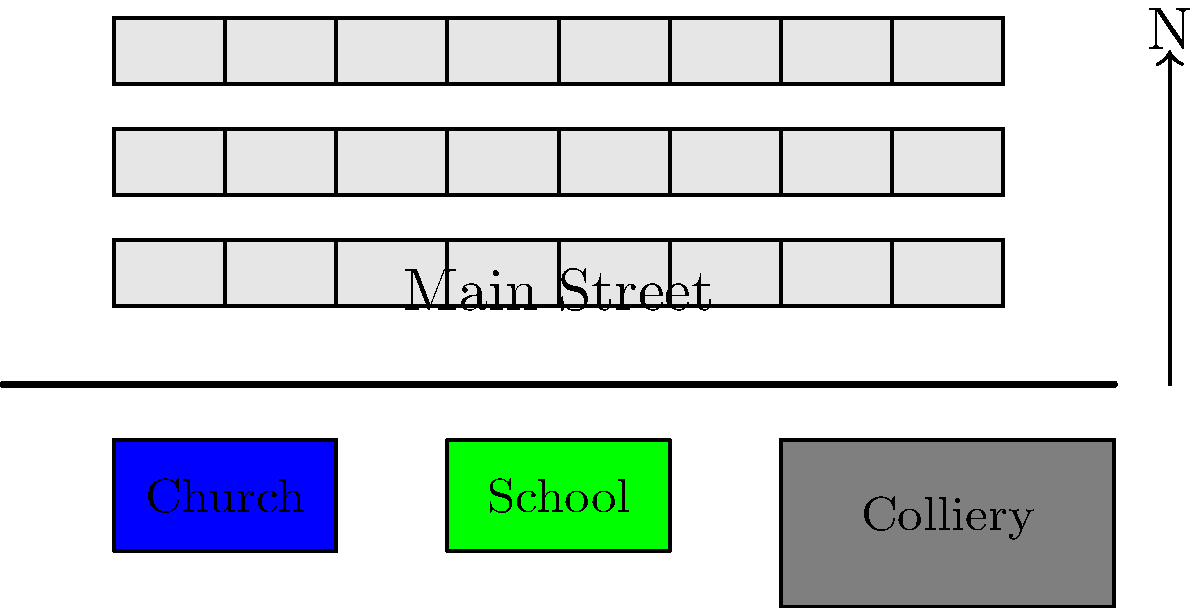In the typical layout of a Northumberland pit village, what is the significance of the positioning of the colliery in relation to the residential area, and how does this arrangement reflect the socio-economic structure of these communities? To understand the significance of the colliery's position in a Northumberland pit village, we need to consider several factors:

1. Proximity: The colliery is typically located at one end of the village, close to the residential area. This proximity allowed miners to easily walk to work, reducing transportation needs.

2. Prevailing winds: The colliery is often positioned downwind from the residential area. This placement helped minimize the impact of coal dust and smoke on the villagers' homes.

3. Social hierarchy: The layout often reflected the social structure of the community. Houses closer to the colliery were usually occupied by miners, while those further away might house managers or other professionals.

4. Community focus: The colliery served as the economic heart of the village, providing employment for most residents. Its prominent position in the village layout emphasized its central role in the community's life.

5. Expansion potential: Placing the colliery at the edge of the village allowed for future expansion of both the mine and the residential area as needed.

6. Safety considerations: The slight separation between the colliery and the houses provided a buffer zone in case of accidents or explosions at the mine.

7. Visual impact: The position of the colliery at the village edge helped maintain a more pleasant residential environment while still keeping the source of employment close by.

This arrangement reflects the socio-economic structure by physically demonstrating the community's dependence on the coal industry, the close-knit nature of mining communities, and the hierarchical organization of mining villages.
Answer: The colliery's edge position balances proximity for workers with safety and environmental concerns, reflecting the community's economic dependence on mining. 